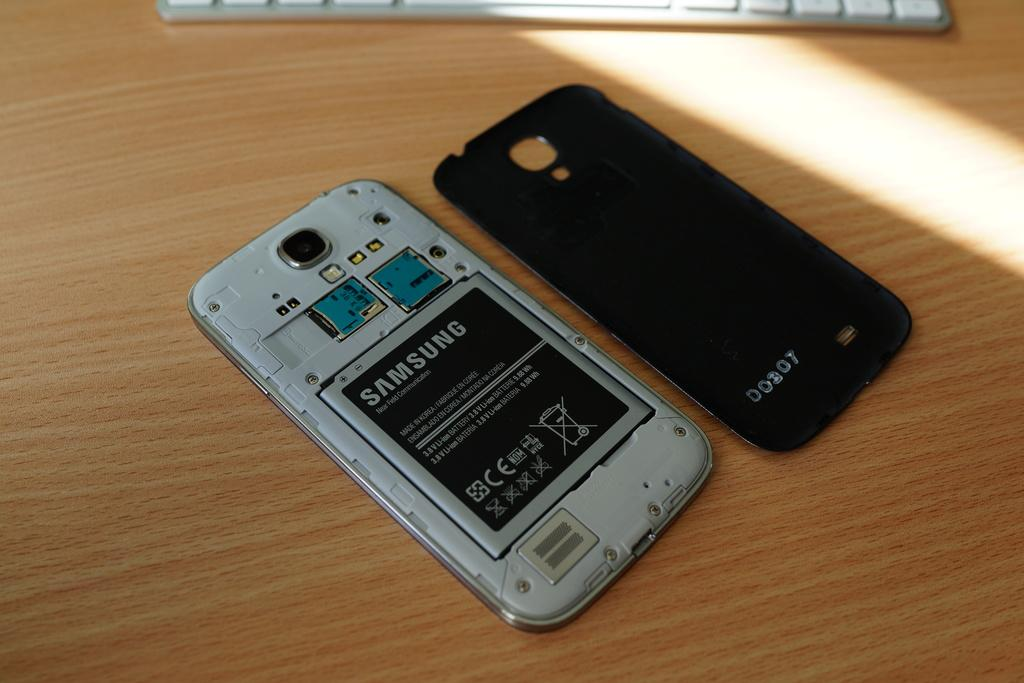<image>
Give a short and clear explanation of the subsequent image. A cellphone with the back removed shows a Samsung battery. 